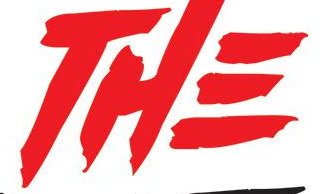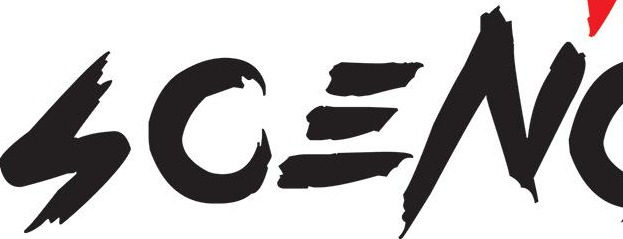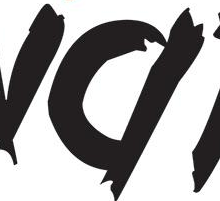Transcribe the words shown in these images in order, separated by a semicolon. THE; SCEN; # 